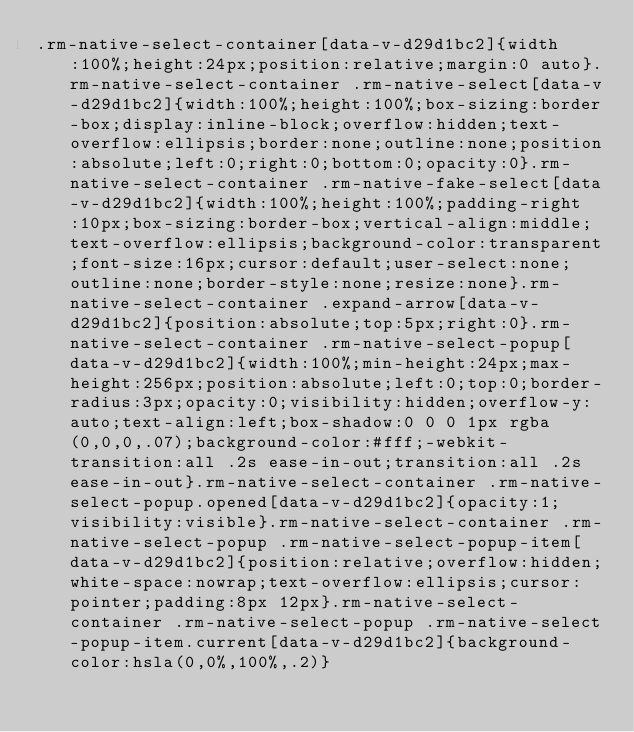<code> <loc_0><loc_0><loc_500><loc_500><_CSS_>.rm-native-select-container[data-v-d29d1bc2]{width:100%;height:24px;position:relative;margin:0 auto}.rm-native-select-container .rm-native-select[data-v-d29d1bc2]{width:100%;height:100%;box-sizing:border-box;display:inline-block;overflow:hidden;text-overflow:ellipsis;border:none;outline:none;position:absolute;left:0;right:0;bottom:0;opacity:0}.rm-native-select-container .rm-native-fake-select[data-v-d29d1bc2]{width:100%;height:100%;padding-right:10px;box-sizing:border-box;vertical-align:middle;text-overflow:ellipsis;background-color:transparent;font-size:16px;cursor:default;user-select:none;outline:none;border-style:none;resize:none}.rm-native-select-container .expand-arrow[data-v-d29d1bc2]{position:absolute;top:5px;right:0}.rm-native-select-container .rm-native-select-popup[data-v-d29d1bc2]{width:100%;min-height:24px;max-height:256px;position:absolute;left:0;top:0;border-radius:3px;opacity:0;visibility:hidden;overflow-y:auto;text-align:left;box-shadow:0 0 0 1px rgba(0,0,0,.07);background-color:#fff;-webkit-transition:all .2s ease-in-out;transition:all .2s ease-in-out}.rm-native-select-container .rm-native-select-popup.opened[data-v-d29d1bc2]{opacity:1;visibility:visible}.rm-native-select-container .rm-native-select-popup .rm-native-select-popup-item[data-v-d29d1bc2]{position:relative;overflow:hidden;white-space:nowrap;text-overflow:ellipsis;cursor:pointer;padding:8px 12px}.rm-native-select-container .rm-native-select-popup .rm-native-select-popup-item.current[data-v-d29d1bc2]{background-color:hsla(0,0%,100%,.2)}</code> 